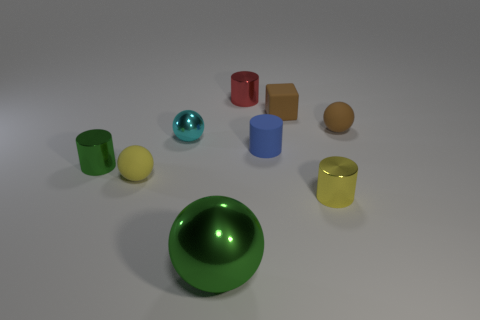Is there anything else that is the same size as the green ball?
Give a very brief answer. No. There is a thing that is the same color as the cube; what is its shape?
Ensure brevity in your answer.  Sphere. There is a small matte thing to the left of the small cyan metallic sphere; is it the same color as the small sphere on the right side of the brown rubber cube?
Give a very brief answer. No. The tiny thing that is in front of the tiny cyan shiny object and right of the blue cylinder has what shape?
Offer a terse response. Cylinder. What is the color of the rubber cube that is the same size as the yellow cylinder?
Provide a succinct answer. Brown. Are there any spheres that have the same color as the small matte block?
Your answer should be compact. Yes. Do the metal sphere behind the small blue cylinder and the metal ball in front of the tiny blue cylinder have the same size?
Your answer should be compact. No. What is the material of the tiny ball that is behind the tiny yellow sphere and on the left side of the small red metal cylinder?
Provide a succinct answer. Metal. What is the size of the ball that is the same color as the rubber block?
Your response must be concise. Small. How many other objects are the same size as the red metallic cylinder?
Ensure brevity in your answer.  7. 